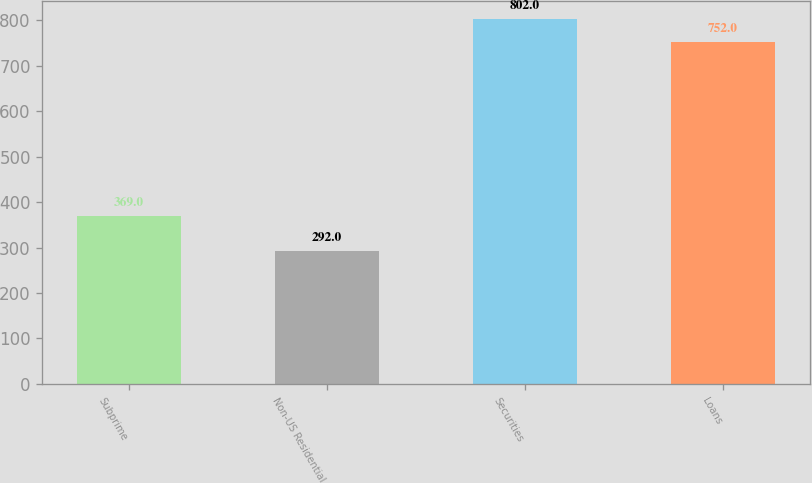Convert chart to OTSL. <chart><loc_0><loc_0><loc_500><loc_500><bar_chart><fcel>Subprime<fcel>Non-US Residential<fcel>Securities<fcel>Loans<nl><fcel>369<fcel>292<fcel>802<fcel>752<nl></chart> 